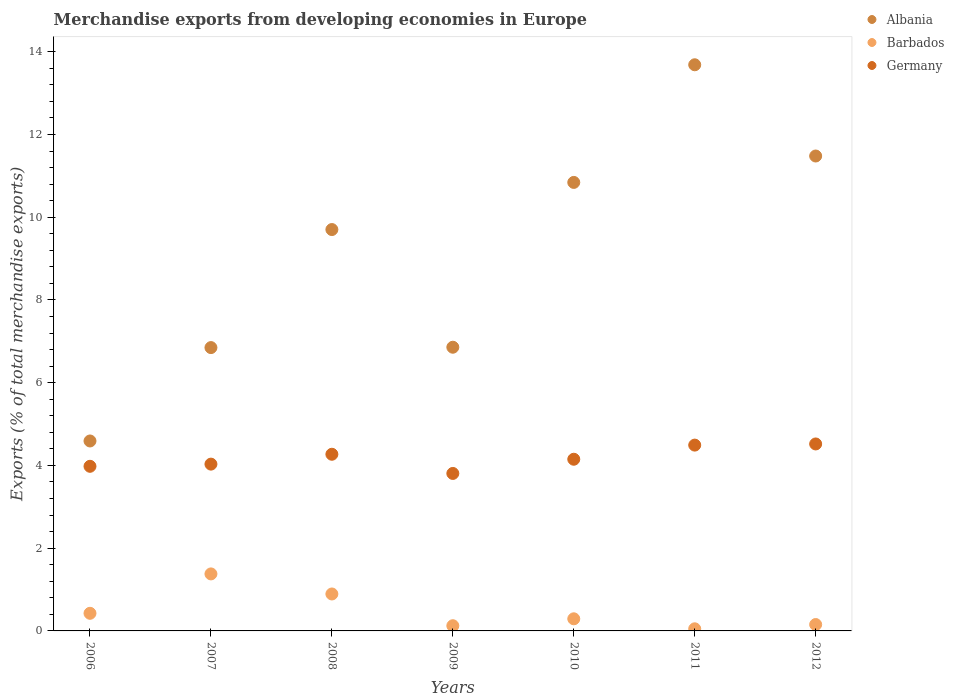How many different coloured dotlines are there?
Your response must be concise. 3. What is the percentage of total merchandise exports in Germany in 2007?
Provide a short and direct response. 4.03. Across all years, what is the maximum percentage of total merchandise exports in Barbados?
Your answer should be compact. 1.38. Across all years, what is the minimum percentage of total merchandise exports in Albania?
Provide a succinct answer. 4.59. In which year was the percentage of total merchandise exports in Barbados maximum?
Offer a terse response. 2007. What is the total percentage of total merchandise exports in Germany in the graph?
Your answer should be very brief. 29.25. What is the difference between the percentage of total merchandise exports in Germany in 2007 and that in 2008?
Your response must be concise. -0.24. What is the difference between the percentage of total merchandise exports in Germany in 2007 and the percentage of total merchandise exports in Albania in 2012?
Your answer should be compact. -7.45. What is the average percentage of total merchandise exports in Albania per year?
Offer a terse response. 9.14. In the year 2009, what is the difference between the percentage of total merchandise exports in Barbados and percentage of total merchandise exports in Albania?
Give a very brief answer. -6.73. In how many years, is the percentage of total merchandise exports in Albania greater than 2 %?
Ensure brevity in your answer.  7. What is the ratio of the percentage of total merchandise exports in Barbados in 2006 to that in 2012?
Your answer should be very brief. 2.76. Is the percentage of total merchandise exports in Albania in 2008 less than that in 2012?
Make the answer very short. Yes. What is the difference between the highest and the second highest percentage of total merchandise exports in Albania?
Your answer should be very brief. 2.21. What is the difference between the highest and the lowest percentage of total merchandise exports in Germany?
Offer a terse response. 0.71. How many years are there in the graph?
Provide a succinct answer. 7. What is the difference between two consecutive major ticks on the Y-axis?
Your answer should be compact. 2. How many legend labels are there?
Give a very brief answer. 3. How are the legend labels stacked?
Offer a very short reply. Vertical. What is the title of the graph?
Offer a very short reply. Merchandise exports from developing economies in Europe. What is the label or title of the Y-axis?
Offer a terse response. Exports (% of total merchandise exports). What is the Exports (% of total merchandise exports) of Albania in 2006?
Ensure brevity in your answer.  4.59. What is the Exports (% of total merchandise exports) of Barbados in 2006?
Your response must be concise. 0.43. What is the Exports (% of total merchandise exports) in Germany in 2006?
Your response must be concise. 3.98. What is the Exports (% of total merchandise exports) of Albania in 2007?
Ensure brevity in your answer.  6.85. What is the Exports (% of total merchandise exports) of Barbados in 2007?
Provide a short and direct response. 1.38. What is the Exports (% of total merchandise exports) in Germany in 2007?
Provide a succinct answer. 4.03. What is the Exports (% of total merchandise exports) of Albania in 2008?
Provide a succinct answer. 9.7. What is the Exports (% of total merchandise exports) in Barbados in 2008?
Ensure brevity in your answer.  0.89. What is the Exports (% of total merchandise exports) in Germany in 2008?
Offer a terse response. 4.27. What is the Exports (% of total merchandise exports) in Albania in 2009?
Your answer should be very brief. 6.86. What is the Exports (% of total merchandise exports) in Barbados in 2009?
Keep it short and to the point. 0.13. What is the Exports (% of total merchandise exports) of Germany in 2009?
Your answer should be compact. 3.81. What is the Exports (% of total merchandise exports) of Albania in 2010?
Offer a terse response. 10.84. What is the Exports (% of total merchandise exports) in Barbados in 2010?
Offer a terse response. 0.29. What is the Exports (% of total merchandise exports) in Germany in 2010?
Give a very brief answer. 4.15. What is the Exports (% of total merchandise exports) of Albania in 2011?
Your response must be concise. 13.69. What is the Exports (% of total merchandise exports) of Barbados in 2011?
Your answer should be very brief. 0.05. What is the Exports (% of total merchandise exports) in Germany in 2011?
Keep it short and to the point. 4.49. What is the Exports (% of total merchandise exports) of Albania in 2012?
Your answer should be compact. 11.48. What is the Exports (% of total merchandise exports) in Barbados in 2012?
Your response must be concise. 0.15. What is the Exports (% of total merchandise exports) of Germany in 2012?
Offer a very short reply. 4.52. Across all years, what is the maximum Exports (% of total merchandise exports) of Albania?
Give a very brief answer. 13.69. Across all years, what is the maximum Exports (% of total merchandise exports) in Barbados?
Your response must be concise. 1.38. Across all years, what is the maximum Exports (% of total merchandise exports) in Germany?
Your answer should be compact. 4.52. Across all years, what is the minimum Exports (% of total merchandise exports) of Albania?
Offer a terse response. 4.59. Across all years, what is the minimum Exports (% of total merchandise exports) of Barbados?
Give a very brief answer. 0.05. Across all years, what is the minimum Exports (% of total merchandise exports) of Germany?
Your response must be concise. 3.81. What is the total Exports (% of total merchandise exports) in Albania in the graph?
Your answer should be compact. 64.01. What is the total Exports (% of total merchandise exports) in Barbados in the graph?
Provide a short and direct response. 3.32. What is the total Exports (% of total merchandise exports) in Germany in the graph?
Keep it short and to the point. 29.25. What is the difference between the Exports (% of total merchandise exports) in Albania in 2006 and that in 2007?
Offer a terse response. -2.26. What is the difference between the Exports (% of total merchandise exports) of Barbados in 2006 and that in 2007?
Keep it short and to the point. -0.95. What is the difference between the Exports (% of total merchandise exports) in Germany in 2006 and that in 2007?
Give a very brief answer. -0.05. What is the difference between the Exports (% of total merchandise exports) in Albania in 2006 and that in 2008?
Provide a succinct answer. -5.11. What is the difference between the Exports (% of total merchandise exports) in Barbados in 2006 and that in 2008?
Offer a terse response. -0.47. What is the difference between the Exports (% of total merchandise exports) in Germany in 2006 and that in 2008?
Make the answer very short. -0.29. What is the difference between the Exports (% of total merchandise exports) in Albania in 2006 and that in 2009?
Provide a succinct answer. -2.27. What is the difference between the Exports (% of total merchandise exports) in Barbados in 2006 and that in 2009?
Provide a short and direct response. 0.3. What is the difference between the Exports (% of total merchandise exports) of Germany in 2006 and that in 2009?
Offer a very short reply. 0.17. What is the difference between the Exports (% of total merchandise exports) of Albania in 2006 and that in 2010?
Offer a terse response. -6.25. What is the difference between the Exports (% of total merchandise exports) of Barbados in 2006 and that in 2010?
Provide a succinct answer. 0.13. What is the difference between the Exports (% of total merchandise exports) in Germany in 2006 and that in 2010?
Your answer should be very brief. -0.17. What is the difference between the Exports (% of total merchandise exports) in Albania in 2006 and that in 2011?
Offer a very short reply. -9.09. What is the difference between the Exports (% of total merchandise exports) in Barbados in 2006 and that in 2011?
Your answer should be compact. 0.37. What is the difference between the Exports (% of total merchandise exports) of Germany in 2006 and that in 2011?
Ensure brevity in your answer.  -0.51. What is the difference between the Exports (% of total merchandise exports) in Albania in 2006 and that in 2012?
Your answer should be compact. -6.89. What is the difference between the Exports (% of total merchandise exports) in Barbados in 2006 and that in 2012?
Your answer should be very brief. 0.27. What is the difference between the Exports (% of total merchandise exports) in Germany in 2006 and that in 2012?
Provide a short and direct response. -0.54. What is the difference between the Exports (% of total merchandise exports) in Albania in 2007 and that in 2008?
Your response must be concise. -2.85. What is the difference between the Exports (% of total merchandise exports) of Barbados in 2007 and that in 2008?
Keep it short and to the point. 0.48. What is the difference between the Exports (% of total merchandise exports) of Germany in 2007 and that in 2008?
Keep it short and to the point. -0.24. What is the difference between the Exports (% of total merchandise exports) in Albania in 2007 and that in 2009?
Your response must be concise. -0.01. What is the difference between the Exports (% of total merchandise exports) of Barbados in 2007 and that in 2009?
Your response must be concise. 1.25. What is the difference between the Exports (% of total merchandise exports) of Germany in 2007 and that in 2009?
Give a very brief answer. 0.23. What is the difference between the Exports (% of total merchandise exports) of Albania in 2007 and that in 2010?
Keep it short and to the point. -3.99. What is the difference between the Exports (% of total merchandise exports) of Barbados in 2007 and that in 2010?
Your answer should be compact. 1.09. What is the difference between the Exports (% of total merchandise exports) of Germany in 2007 and that in 2010?
Give a very brief answer. -0.12. What is the difference between the Exports (% of total merchandise exports) in Albania in 2007 and that in 2011?
Your answer should be very brief. -6.84. What is the difference between the Exports (% of total merchandise exports) in Barbados in 2007 and that in 2011?
Ensure brevity in your answer.  1.33. What is the difference between the Exports (% of total merchandise exports) in Germany in 2007 and that in 2011?
Keep it short and to the point. -0.46. What is the difference between the Exports (% of total merchandise exports) in Albania in 2007 and that in 2012?
Ensure brevity in your answer.  -4.63. What is the difference between the Exports (% of total merchandise exports) of Barbados in 2007 and that in 2012?
Your answer should be compact. 1.22. What is the difference between the Exports (% of total merchandise exports) in Germany in 2007 and that in 2012?
Keep it short and to the point. -0.49. What is the difference between the Exports (% of total merchandise exports) in Albania in 2008 and that in 2009?
Your response must be concise. 2.84. What is the difference between the Exports (% of total merchandise exports) in Barbados in 2008 and that in 2009?
Ensure brevity in your answer.  0.77. What is the difference between the Exports (% of total merchandise exports) in Germany in 2008 and that in 2009?
Your answer should be compact. 0.46. What is the difference between the Exports (% of total merchandise exports) of Albania in 2008 and that in 2010?
Provide a short and direct response. -1.14. What is the difference between the Exports (% of total merchandise exports) in Barbados in 2008 and that in 2010?
Provide a succinct answer. 0.6. What is the difference between the Exports (% of total merchandise exports) in Germany in 2008 and that in 2010?
Ensure brevity in your answer.  0.12. What is the difference between the Exports (% of total merchandise exports) of Albania in 2008 and that in 2011?
Your answer should be very brief. -3.98. What is the difference between the Exports (% of total merchandise exports) of Barbados in 2008 and that in 2011?
Provide a short and direct response. 0.84. What is the difference between the Exports (% of total merchandise exports) of Germany in 2008 and that in 2011?
Your answer should be compact. -0.22. What is the difference between the Exports (% of total merchandise exports) of Albania in 2008 and that in 2012?
Give a very brief answer. -1.78. What is the difference between the Exports (% of total merchandise exports) in Barbados in 2008 and that in 2012?
Give a very brief answer. 0.74. What is the difference between the Exports (% of total merchandise exports) of Germany in 2008 and that in 2012?
Keep it short and to the point. -0.25. What is the difference between the Exports (% of total merchandise exports) in Albania in 2009 and that in 2010?
Keep it short and to the point. -3.98. What is the difference between the Exports (% of total merchandise exports) in Barbados in 2009 and that in 2010?
Make the answer very short. -0.17. What is the difference between the Exports (% of total merchandise exports) in Germany in 2009 and that in 2010?
Offer a terse response. -0.34. What is the difference between the Exports (% of total merchandise exports) in Albania in 2009 and that in 2011?
Your answer should be very brief. -6.83. What is the difference between the Exports (% of total merchandise exports) in Barbados in 2009 and that in 2011?
Your answer should be compact. 0.07. What is the difference between the Exports (% of total merchandise exports) in Germany in 2009 and that in 2011?
Your answer should be very brief. -0.69. What is the difference between the Exports (% of total merchandise exports) of Albania in 2009 and that in 2012?
Give a very brief answer. -4.62. What is the difference between the Exports (% of total merchandise exports) in Barbados in 2009 and that in 2012?
Keep it short and to the point. -0.03. What is the difference between the Exports (% of total merchandise exports) of Germany in 2009 and that in 2012?
Make the answer very short. -0.71. What is the difference between the Exports (% of total merchandise exports) of Albania in 2010 and that in 2011?
Your answer should be compact. -2.84. What is the difference between the Exports (% of total merchandise exports) of Barbados in 2010 and that in 2011?
Your response must be concise. 0.24. What is the difference between the Exports (% of total merchandise exports) of Germany in 2010 and that in 2011?
Give a very brief answer. -0.34. What is the difference between the Exports (% of total merchandise exports) of Albania in 2010 and that in 2012?
Keep it short and to the point. -0.64. What is the difference between the Exports (% of total merchandise exports) of Barbados in 2010 and that in 2012?
Provide a succinct answer. 0.14. What is the difference between the Exports (% of total merchandise exports) in Germany in 2010 and that in 2012?
Offer a terse response. -0.37. What is the difference between the Exports (% of total merchandise exports) of Albania in 2011 and that in 2012?
Ensure brevity in your answer.  2.21. What is the difference between the Exports (% of total merchandise exports) of Barbados in 2011 and that in 2012?
Make the answer very short. -0.1. What is the difference between the Exports (% of total merchandise exports) in Germany in 2011 and that in 2012?
Give a very brief answer. -0.03. What is the difference between the Exports (% of total merchandise exports) of Albania in 2006 and the Exports (% of total merchandise exports) of Barbados in 2007?
Your response must be concise. 3.21. What is the difference between the Exports (% of total merchandise exports) in Albania in 2006 and the Exports (% of total merchandise exports) in Germany in 2007?
Your response must be concise. 0.56. What is the difference between the Exports (% of total merchandise exports) in Barbados in 2006 and the Exports (% of total merchandise exports) in Germany in 2007?
Keep it short and to the point. -3.61. What is the difference between the Exports (% of total merchandise exports) in Albania in 2006 and the Exports (% of total merchandise exports) in Barbados in 2008?
Your response must be concise. 3.7. What is the difference between the Exports (% of total merchandise exports) of Albania in 2006 and the Exports (% of total merchandise exports) of Germany in 2008?
Give a very brief answer. 0.32. What is the difference between the Exports (% of total merchandise exports) of Barbados in 2006 and the Exports (% of total merchandise exports) of Germany in 2008?
Make the answer very short. -3.84. What is the difference between the Exports (% of total merchandise exports) in Albania in 2006 and the Exports (% of total merchandise exports) in Barbados in 2009?
Offer a very short reply. 4.47. What is the difference between the Exports (% of total merchandise exports) in Albania in 2006 and the Exports (% of total merchandise exports) in Germany in 2009?
Your response must be concise. 0.79. What is the difference between the Exports (% of total merchandise exports) in Barbados in 2006 and the Exports (% of total merchandise exports) in Germany in 2009?
Make the answer very short. -3.38. What is the difference between the Exports (% of total merchandise exports) of Albania in 2006 and the Exports (% of total merchandise exports) of Barbados in 2010?
Keep it short and to the point. 4.3. What is the difference between the Exports (% of total merchandise exports) in Albania in 2006 and the Exports (% of total merchandise exports) in Germany in 2010?
Offer a terse response. 0.44. What is the difference between the Exports (% of total merchandise exports) of Barbados in 2006 and the Exports (% of total merchandise exports) of Germany in 2010?
Offer a very short reply. -3.72. What is the difference between the Exports (% of total merchandise exports) of Albania in 2006 and the Exports (% of total merchandise exports) of Barbados in 2011?
Provide a succinct answer. 4.54. What is the difference between the Exports (% of total merchandise exports) of Albania in 2006 and the Exports (% of total merchandise exports) of Germany in 2011?
Make the answer very short. 0.1. What is the difference between the Exports (% of total merchandise exports) in Barbados in 2006 and the Exports (% of total merchandise exports) in Germany in 2011?
Ensure brevity in your answer.  -4.07. What is the difference between the Exports (% of total merchandise exports) of Albania in 2006 and the Exports (% of total merchandise exports) of Barbados in 2012?
Give a very brief answer. 4.44. What is the difference between the Exports (% of total merchandise exports) of Albania in 2006 and the Exports (% of total merchandise exports) of Germany in 2012?
Your response must be concise. 0.07. What is the difference between the Exports (% of total merchandise exports) of Barbados in 2006 and the Exports (% of total merchandise exports) of Germany in 2012?
Give a very brief answer. -4.09. What is the difference between the Exports (% of total merchandise exports) in Albania in 2007 and the Exports (% of total merchandise exports) in Barbados in 2008?
Your answer should be compact. 5.96. What is the difference between the Exports (% of total merchandise exports) in Albania in 2007 and the Exports (% of total merchandise exports) in Germany in 2008?
Make the answer very short. 2.58. What is the difference between the Exports (% of total merchandise exports) of Barbados in 2007 and the Exports (% of total merchandise exports) of Germany in 2008?
Give a very brief answer. -2.89. What is the difference between the Exports (% of total merchandise exports) in Albania in 2007 and the Exports (% of total merchandise exports) in Barbados in 2009?
Make the answer very short. 6.72. What is the difference between the Exports (% of total merchandise exports) of Albania in 2007 and the Exports (% of total merchandise exports) of Germany in 2009?
Make the answer very short. 3.04. What is the difference between the Exports (% of total merchandise exports) of Barbados in 2007 and the Exports (% of total merchandise exports) of Germany in 2009?
Your answer should be compact. -2.43. What is the difference between the Exports (% of total merchandise exports) of Albania in 2007 and the Exports (% of total merchandise exports) of Barbados in 2010?
Offer a very short reply. 6.56. What is the difference between the Exports (% of total merchandise exports) in Albania in 2007 and the Exports (% of total merchandise exports) in Germany in 2010?
Make the answer very short. 2.7. What is the difference between the Exports (% of total merchandise exports) of Barbados in 2007 and the Exports (% of total merchandise exports) of Germany in 2010?
Provide a succinct answer. -2.77. What is the difference between the Exports (% of total merchandise exports) of Albania in 2007 and the Exports (% of total merchandise exports) of Barbados in 2011?
Provide a succinct answer. 6.8. What is the difference between the Exports (% of total merchandise exports) of Albania in 2007 and the Exports (% of total merchandise exports) of Germany in 2011?
Your response must be concise. 2.36. What is the difference between the Exports (% of total merchandise exports) of Barbados in 2007 and the Exports (% of total merchandise exports) of Germany in 2011?
Provide a succinct answer. -3.11. What is the difference between the Exports (% of total merchandise exports) in Albania in 2007 and the Exports (% of total merchandise exports) in Barbados in 2012?
Your answer should be very brief. 6.69. What is the difference between the Exports (% of total merchandise exports) in Albania in 2007 and the Exports (% of total merchandise exports) in Germany in 2012?
Your answer should be compact. 2.33. What is the difference between the Exports (% of total merchandise exports) of Barbados in 2007 and the Exports (% of total merchandise exports) of Germany in 2012?
Give a very brief answer. -3.14. What is the difference between the Exports (% of total merchandise exports) in Albania in 2008 and the Exports (% of total merchandise exports) in Barbados in 2009?
Your answer should be compact. 9.58. What is the difference between the Exports (% of total merchandise exports) of Albania in 2008 and the Exports (% of total merchandise exports) of Germany in 2009?
Your answer should be compact. 5.9. What is the difference between the Exports (% of total merchandise exports) in Barbados in 2008 and the Exports (% of total merchandise exports) in Germany in 2009?
Give a very brief answer. -2.91. What is the difference between the Exports (% of total merchandise exports) in Albania in 2008 and the Exports (% of total merchandise exports) in Barbados in 2010?
Provide a short and direct response. 9.41. What is the difference between the Exports (% of total merchandise exports) in Albania in 2008 and the Exports (% of total merchandise exports) in Germany in 2010?
Offer a very short reply. 5.55. What is the difference between the Exports (% of total merchandise exports) in Barbados in 2008 and the Exports (% of total merchandise exports) in Germany in 2010?
Provide a short and direct response. -3.26. What is the difference between the Exports (% of total merchandise exports) in Albania in 2008 and the Exports (% of total merchandise exports) in Barbados in 2011?
Provide a succinct answer. 9.65. What is the difference between the Exports (% of total merchandise exports) of Albania in 2008 and the Exports (% of total merchandise exports) of Germany in 2011?
Offer a terse response. 5.21. What is the difference between the Exports (% of total merchandise exports) in Barbados in 2008 and the Exports (% of total merchandise exports) in Germany in 2011?
Give a very brief answer. -3.6. What is the difference between the Exports (% of total merchandise exports) of Albania in 2008 and the Exports (% of total merchandise exports) of Barbados in 2012?
Your response must be concise. 9.55. What is the difference between the Exports (% of total merchandise exports) in Albania in 2008 and the Exports (% of total merchandise exports) in Germany in 2012?
Make the answer very short. 5.18. What is the difference between the Exports (% of total merchandise exports) of Barbados in 2008 and the Exports (% of total merchandise exports) of Germany in 2012?
Ensure brevity in your answer.  -3.63. What is the difference between the Exports (% of total merchandise exports) of Albania in 2009 and the Exports (% of total merchandise exports) of Barbados in 2010?
Your answer should be very brief. 6.56. What is the difference between the Exports (% of total merchandise exports) of Albania in 2009 and the Exports (% of total merchandise exports) of Germany in 2010?
Your response must be concise. 2.71. What is the difference between the Exports (% of total merchandise exports) of Barbados in 2009 and the Exports (% of total merchandise exports) of Germany in 2010?
Give a very brief answer. -4.02. What is the difference between the Exports (% of total merchandise exports) in Albania in 2009 and the Exports (% of total merchandise exports) in Barbados in 2011?
Offer a terse response. 6.81. What is the difference between the Exports (% of total merchandise exports) in Albania in 2009 and the Exports (% of total merchandise exports) in Germany in 2011?
Provide a succinct answer. 2.37. What is the difference between the Exports (% of total merchandise exports) of Barbados in 2009 and the Exports (% of total merchandise exports) of Germany in 2011?
Your response must be concise. -4.37. What is the difference between the Exports (% of total merchandise exports) in Albania in 2009 and the Exports (% of total merchandise exports) in Barbados in 2012?
Offer a very short reply. 6.7. What is the difference between the Exports (% of total merchandise exports) in Albania in 2009 and the Exports (% of total merchandise exports) in Germany in 2012?
Offer a terse response. 2.34. What is the difference between the Exports (% of total merchandise exports) of Barbados in 2009 and the Exports (% of total merchandise exports) of Germany in 2012?
Your answer should be compact. -4.39. What is the difference between the Exports (% of total merchandise exports) of Albania in 2010 and the Exports (% of total merchandise exports) of Barbados in 2011?
Your response must be concise. 10.79. What is the difference between the Exports (% of total merchandise exports) of Albania in 2010 and the Exports (% of total merchandise exports) of Germany in 2011?
Offer a terse response. 6.35. What is the difference between the Exports (% of total merchandise exports) in Barbados in 2010 and the Exports (% of total merchandise exports) in Germany in 2011?
Your answer should be compact. -4.2. What is the difference between the Exports (% of total merchandise exports) of Albania in 2010 and the Exports (% of total merchandise exports) of Barbados in 2012?
Give a very brief answer. 10.69. What is the difference between the Exports (% of total merchandise exports) of Albania in 2010 and the Exports (% of total merchandise exports) of Germany in 2012?
Provide a short and direct response. 6.32. What is the difference between the Exports (% of total merchandise exports) of Barbados in 2010 and the Exports (% of total merchandise exports) of Germany in 2012?
Keep it short and to the point. -4.23. What is the difference between the Exports (% of total merchandise exports) of Albania in 2011 and the Exports (% of total merchandise exports) of Barbados in 2012?
Make the answer very short. 13.53. What is the difference between the Exports (% of total merchandise exports) of Albania in 2011 and the Exports (% of total merchandise exports) of Germany in 2012?
Offer a very short reply. 9.17. What is the difference between the Exports (% of total merchandise exports) of Barbados in 2011 and the Exports (% of total merchandise exports) of Germany in 2012?
Ensure brevity in your answer.  -4.47. What is the average Exports (% of total merchandise exports) of Albania per year?
Ensure brevity in your answer.  9.14. What is the average Exports (% of total merchandise exports) in Barbados per year?
Keep it short and to the point. 0.47. What is the average Exports (% of total merchandise exports) in Germany per year?
Offer a very short reply. 4.18. In the year 2006, what is the difference between the Exports (% of total merchandise exports) of Albania and Exports (% of total merchandise exports) of Barbados?
Keep it short and to the point. 4.17. In the year 2006, what is the difference between the Exports (% of total merchandise exports) in Albania and Exports (% of total merchandise exports) in Germany?
Your answer should be very brief. 0.61. In the year 2006, what is the difference between the Exports (% of total merchandise exports) in Barbados and Exports (% of total merchandise exports) in Germany?
Provide a short and direct response. -3.55. In the year 2007, what is the difference between the Exports (% of total merchandise exports) of Albania and Exports (% of total merchandise exports) of Barbados?
Offer a terse response. 5.47. In the year 2007, what is the difference between the Exports (% of total merchandise exports) of Albania and Exports (% of total merchandise exports) of Germany?
Provide a succinct answer. 2.82. In the year 2007, what is the difference between the Exports (% of total merchandise exports) of Barbados and Exports (% of total merchandise exports) of Germany?
Keep it short and to the point. -2.65. In the year 2008, what is the difference between the Exports (% of total merchandise exports) in Albania and Exports (% of total merchandise exports) in Barbados?
Provide a short and direct response. 8.81. In the year 2008, what is the difference between the Exports (% of total merchandise exports) of Albania and Exports (% of total merchandise exports) of Germany?
Make the answer very short. 5.43. In the year 2008, what is the difference between the Exports (% of total merchandise exports) in Barbados and Exports (% of total merchandise exports) in Germany?
Offer a very short reply. -3.38. In the year 2009, what is the difference between the Exports (% of total merchandise exports) in Albania and Exports (% of total merchandise exports) in Barbados?
Your answer should be compact. 6.73. In the year 2009, what is the difference between the Exports (% of total merchandise exports) in Albania and Exports (% of total merchandise exports) in Germany?
Ensure brevity in your answer.  3.05. In the year 2009, what is the difference between the Exports (% of total merchandise exports) of Barbados and Exports (% of total merchandise exports) of Germany?
Make the answer very short. -3.68. In the year 2010, what is the difference between the Exports (% of total merchandise exports) of Albania and Exports (% of total merchandise exports) of Barbados?
Provide a succinct answer. 10.55. In the year 2010, what is the difference between the Exports (% of total merchandise exports) in Albania and Exports (% of total merchandise exports) in Germany?
Ensure brevity in your answer.  6.69. In the year 2010, what is the difference between the Exports (% of total merchandise exports) in Barbados and Exports (% of total merchandise exports) in Germany?
Offer a terse response. -3.86. In the year 2011, what is the difference between the Exports (% of total merchandise exports) of Albania and Exports (% of total merchandise exports) of Barbados?
Provide a succinct answer. 13.63. In the year 2011, what is the difference between the Exports (% of total merchandise exports) in Albania and Exports (% of total merchandise exports) in Germany?
Your answer should be compact. 9.19. In the year 2011, what is the difference between the Exports (% of total merchandise exports) in Barbados and Exports (% of total merchandise exports) in Germany?
Provide a short and direct response. -4.44. In the year 2012, what is the difference between the Exports (% of total merchandise exports) in Albania and Exports (% of total merchandise exports) in Barbados?
Your answer should be very brief. 11.33. In the year 2012, what is the difference between the Exports (% of total merchandise exports) of Albania and Exports (% of total merchandise exports) of Germany?
Offer a very short reply. 6.96. In the year 2012, what is the difference between the Exports (% of total merchandise exports) of Barbados and Exports (% of total merchandise exports) of Germany?
Offer a terse response. -4.37. What is the ratio of the Exports (% of total merchandise exports) in Albania in 2006 to that in 2007?
Your response must be concise. 0.67. What is the ratio of the Exports (% of total merchandise exports) in Barbados in 2006 to that in 2007?
Ensure brevity in your answer.  0.31. What is the ratio of the Exports (% of total merchandise exports) of Germany in 2006 to that in 2007?
Keep it short and to the point. 0.99. What is the ratio of the Exports (% of total merchandise exports) in Albania in 2006 to that in 2008?
Your answer should be compact. 0.47. What is the ratio of the Exports (% of total merchandise exports) in Barbados in 2006 to that in 2008?
Your answer should be compact. 0.48. What is the ratio of the Exports (% of total merchandise exports) of Germany in 2006 to that in 2008?
Give a very brief answer. 0.93. What is the ratio of the Exports (% of total merchandise exports) of Albania in 2006 to that in 2009?
Make the answer very short. 0.67. What is the ratio of the Exports (% of total merchandise exports) in Barbados in 2006 to that in 2009?
Offer a terse response. 3.39. What is the ratio of the Exports (% of total merchandise exports) in Germany in 2006 to that in 2009?
Keep it short and to the point. 1.05. What is the ratio of the Exports (% of total merchandise exports) of Albania in 2006 to that in 2010?
Make the answer very short. 0.42. What is the ratio of the Exports (% of total merchandise exports) of Barbados in 2006 to that in 2010?
Make the answer very short. 1.45. What is the ratio of the Exports (% of total merchandise exports) in Germany in 2006 to that in 2010?
Make the answer very short. 0.96. What is the ratio of the Exports (% of total merchandise exports) of Albania in 2006 to that in 2011?
Give a very brief answer. 0.34. What is the ratio of the Exports (% of total merchandise exports) of Barbados in 2006 to that in 2011?
Offer a terse response. 8.31. What is the ratio of the Exports (% of total merchandise exports) in Germany in 2006 to that in 2011?
Make the answer very short. 0.89. What is the ratio of the Exports (% of total merchandise exports) in Barbados in 2006 to that in 2012?
Keep it short and to the point. 2.76. What is the ratio of the Exports (% of total merchandise exports) of Germany in 2006 to that in 2012?
Your answer should be compact. 0.88. What is the ratio of the Exports (% of total merchandise exports) in Albania in 2007 to that in 2008?
Offer a very short reply. 0.71. What is the ratio of the Exports (% of total merchandise exports) of Barbados in 2007 to that in 2008?
Your answer should be very brief. 1.54. What is the ratio of the Exports (% of total merchandise exports) of Germany in 2007 to that in 2008?
Your response must be concise. 0.94. What is the ratio of the Exports (% of total merchandise exports) of Albania in 2007 to that in 2009?
Your answer should be compact. 1. What is the ratio of the Exports (% of total merchandise exports) in Barbados in 2007 to that in 2009?
Your answer should be very brief. 10.97. What is the ratio of the Exports (% of total merchandise exports) in Germany in 2007 to that in 2009?
Your response must be concise. 1.06. What is the ratio of the Exports (% of total merchandise exports) of Albania in 2007 to that in 2010?
Ensure brevity in your answer.  0.63. What is the ratio of the Exports (% of total merchandise exports) in Barbados in 2007 to that in 2010?
Your response must be concise. 4.71. What is the ratio of the Exports (% of total merchandise exports) in Germany in 2007 to that in 2010?
Ensure brevity in your answer.  0.97. What is the ratio of the Exports (% of total merchandise exports) in Albania in 2007 to that in 2011?
Ensure brevity in your answer.  0.5. What is the ratio of the Exports (% of total merchandise exports) in Barbados in 2007 to that in 2011?
Your response must be concise. 26.89. What is the ratio of the Exports (% of total merchandise exports) of Germany in 2007 to that in 2011?
Provide a succinct answer. 0.9. What is the ratio of the Exports (% of total merchandise exports) of Albania in 2007 to that in 2012?
Offer a terse response. 0.6. What is the ratio of the Exports (% of total merchandise exports) in Barbados in 2007 to that in 2012?
Give a very brief answer. 8.92. What is the ratio of the Exports (% of total merchandise exports) of Germany in 2007 to that in 2012?
Your answer should be compact. 0.89. What is the ratio of the Exports (% of total merchandise exports) of Albania in 2008 to that in 2009?
Make the answer very short. 1.41. What is the ratio of the Exports (% of total merchandise exports) in Barbados in 2008 to that in 2009?
Provide a short and direct response. 7.11. What is the ratio of the Exports (% of total merchandise exports) of Germany in 2008 to that in 2009?
Your answer should be very brief. 1.12. What is the ratio of the Exports (% of total merchandise exports) in Albania in 2008 to that in 2010?
Make the answer very short. 0.89. What is the ratio of the Exports (% of total merchandise exports) in Barbados in 2008 to that in 2010?
Make the answer very short. 3.05. What is the ratio of the Exports (% of total merchandise exports) of Germany in 2008 to that in 2010?
Your response must be concise. 1.03. What is the ratio of the Exports (% of total merchandise exports) of Albania in 2008 to that in 2011?
Provide a short and direct response. 0.71. What is the ratio of the Exports (% of total merchandise exports) of Barbados in 2008 to that in 2011?
Your response must be concise. 17.43. What is the ratio of the Exports (% of total merchandise exports) of Germany in 2008 to that in 2011?
Ensure brevity in your answer.  0.95. What is the ratio of the Exports (% of total merchandise exports) in Albania in 2008 to that in 2012?
Provide a short and direct response. 0.85. What is the ratio of the Exports (% of total merchandise exports) of Barbados in 2008 to that in 2012?
Your answer should be compact. 5.78. What is the ratio of the Exports (% of total merchandise exports) in Germany in 2008 to that in 2012?
Provide a short and direct response. 0.94. What is the ratio of the Exports (% of total merchandise exports) of Albania in 2009 to that in 2010?
Your answer should be compact. 0.63. What is the ratio of the Exports (% of total merchandise exports) in Barbados in 2009 to that in 2010?
Offer a very short reply. 0.43. What is the ratio of the Exports (% of total merchandise exports) in Germany in 2009 to that in 2010?
Make the answer very short. 0.92. What is the ratio of the Exports (% of total merchandise exports) in Albania in 2009 to that in 2011?
Give a very brief answer. 0.5. What is the ratio of the Exports (% of total merchandise exports) of Barbados in 2009 to that in 2011?
Offer a very short reply. 2.45. What is the ratio of the Exports (% of total merchandise exports) of Germany in 2009 to that in 2011?
Give a very brief answer. 0.85. What is the ratio of the Exports (% of total merchandise exports) in Albania in 2009 to that in 2012?
Ensure brevity in your answer.  0.6. What is the ratio of the Exports (% of total merchandise exports) in Barbados in 2009 to that in 2012?
Make the answer very short. 0.81. What is the ratio of the Exports (% of total merchandise exports) of Germany in 2009 to that in 2012?
Your answer should be compact. 0.84. What is the ratio of the Exports (% of total merchandise exports) of Albania in 2010 to that in 2011?
Provide a succinct answer. 0.79. What is the ratio of the Exports (% of total merchandise exports) of Barbados in 2010 to that in 2011?
Your answer should be very brief. 5.71. What is the ratio of the Exports (% of total merchandise exports) in Germany in 2010 to that in 2011?
Offer a very short reply. 0.92. What is the ratio of the Exports (% of total merchandise exports) in Albania in 2010 to that in 2012?
Your answer should be very brief. 0.94. What is the ratio of the Exports (% of total merchandise exports) in Barbados in 2010 to that in 2012?
Keep it short and to the point. 1.9. What is the ratio of the Exports (% of total merchandise exports) of Germany in 2010 to that in 2012?
Your answer should be very brief. 0.92. What is the ratio of the Exports (% of total merchandise exports) in Albania in 2011 to that in 2012?
Make the answer very short. 1.19. What is the ratio of the Exports (% of total merchandise exports) of Barbados in 2011 to that in 2012?
Give a very brief answer. 0.33. What is the ratio of the Exports (% of total merchandise exports) in Germany in 2011 to that in 2012?
Ensure brevity in your answer.  0.99. What is the difference between the highest and the second highest Exports (% of total merchandise exports) of Albania?
Provide a succinct answer. 2.21. What is the difference between the highest and the second highest Exports (% of total merchandise exports) of Barbados?
Provide a succinct answer. 0.48. What is the difference between the highest and the second highest Exports (% of total merchandise exports) in Germany?
Offer a terse response. 0.03. What is the difference between the highest and the lowest Exports (% of total merchandise exports) of Albania?
Offer a very short reply. 9.09. What is the difference between the highest and the lowest Exports (% of total merchandise exports) in Barbados?
Offer a terse response. 1.33. What is the difference between the highest and the lowest Exports (% of total merchandise exports) in Germany?
Your answer should be compact. 0.71. 